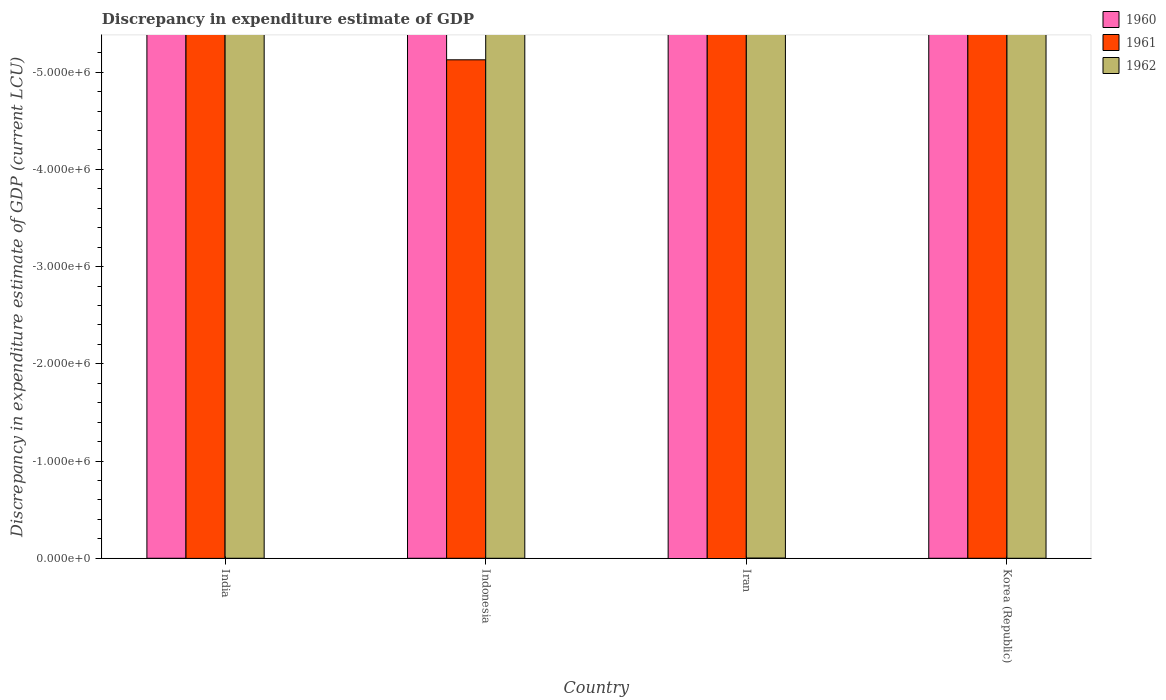Are the number of bars per tick equal to the number of legend labels?
Offer a terse response. No. What is the total discrepancy in expenditure estimate of GDP in 1961 in the graph?
Offer a terse response. 0. In how many countries, is the discrepancy in expenditure estimate of GDP in 1962 greater than -200000 LCU?
Offer a very short reply. 0. Is it the case that in every country, the sum of the discrepancy in expenditure estimate of GDP in 1962 and discrepancy in expenditure estimate of GDP in 1960 is greater than the discrepancy in expenditure estimate of GDP in 1961?
Offer a very short reply. No. How many bars are there?
Offer a terse response. 0. Are all the bars in the graph horizontal?
Your answer should be very brief. No. How many countries are there in the graph?
Give a very brief answer. 4. What is the difference between two consecutive major ticks on the Y-axis?
Your answer should be very brief. 1.00e+06. Are the values on the major ticks of Y-axis written in scientific E-notation?
Make the answer very short. Yes. Does the graph contain any zero values?
Offer a very short reply. Yes. Where does the legend appear in the graph?
Provide a succinct answer. Top right. What is the title of the graph?
Provide a short and direct response. Discrepancy in expenditure estimate of GDP. Does "1972" appear as one of the legend labels in the graph?
Give a very brief answer. No. What is the label or title of the Y-axis?
Your answer should be very brief. Discrepancy in expenditure estimate of GDP (current LCU). What is the Discrepancy in expenditure estimate of GDP (current LCU) of 1962 in India?
Provide a short and direct response. 0. What is the Discrepancy in expenditure estimate of GDP (current LCU) in 1960 in Indonesia?
Your response must be concise. 0. What is the Discrepancy in expenditure estimate of GDP (current LCU) in 1961 in Indonesia?
Your answer should be compact. 0. What is the Discrepancy in expenditure estimate of GDP (current LCU) of 1962 in Iran?
Provide a succinct answer. 0. What is the total Discrepancy in expenditure estimate of GDP (current LCU) in 1960 in the graph?
Keep it short and to the point. 0. What is the average Discrepancy in expenditure estimate of GDP (current LCU) in 1960 per country?
Your answer should be very brief. 0. What is the average Discrepancy in expenditure estimate of GDP (current LCU) of 1961 per country?
Your answer should be compact. 0. 